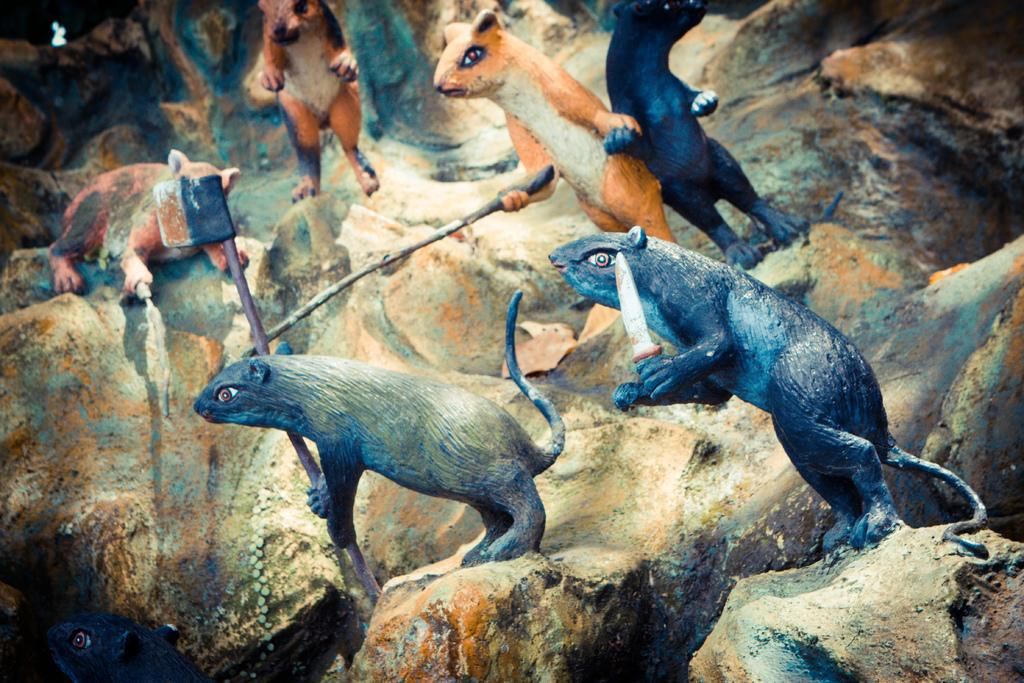What type of animals are depicted in the sculptures in the image? There are sculptures of rats in the image. What are the rats holding in their hands? The rats are holding weapons in their hands. What is the rats standing on in the image? The rats are standing on a rock. What type of lace can be seen on the rats' clothing in the image? There is no lace present on the rats' clothing in the image, as they are depicted as sculptures and not wearing any clothing. 